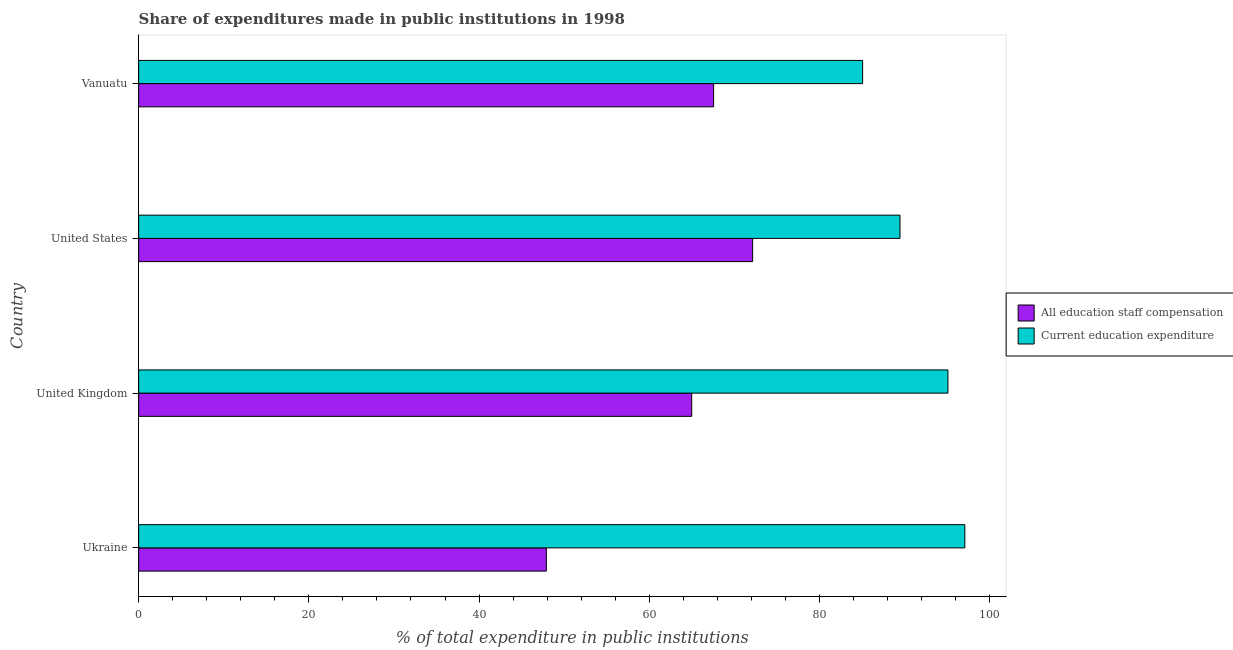How many different coloured bars are there?
Your answer should be very brief. 2. How many groups of bars are there?
Your answer should be very brief. 4. Are the number of bars per tick equal to the number of legend labels?
Keep it short and to the point. Yes. How many bars are there on the 1st tick from the top?
Give a very brief answer. 2. What is the label of the 3rd group of bars from the top?
Your answer should be compact. United Kingdom. In how many cases, is the number of bars for a given country not equal to the number of legend labels?
Offer a terse response. 0. What is the expenditure in staff compensation in Ukraine?
Your answer should be very brief. 47.91. Across all countries, what is the maximum expenditure in education?
Offer a very short reply. 97.07. Across all countries, what is the minimum expenditure in education?
Your answer should be very brief. 85.07. In which country was the expenditure in education minimum?
Keep it short and to the point. Vanuatu. What is the total expenditure in staff compensation in the graph?
Your answer should be very brief. 252.59. What is the difference between the expenditure in education in Ukraine and that in United States?
Your response must be concise. 7.62. What is the difference between the expenditure in education in United States and the expenditure in staff compensation in Ukraine?
Your answer should be very brief. 41.55. What is the average expenditure in education per country?
Offer a very short reply. 91.67. What is the difference between the expenditure in education and expenditure in staff compensation in Ukraine?
Ensure brevity in your answer.  49.17. What is the ratio of the expenditure in staff compensation in United Kingdom to that in United States?
Your answer should be very brief. 0.9. Is the difference between the expenditure in staff compensation in Ukraine and United States greater than the difference between the expenditure in education in Ukraine and United States?
Provide a succinct answer. No. What is the difference between the highest and the second highest expenditure in education?
Keep it short and to the point. 1.99. What is the difference between the highest and the lowest expenditure in education?
Provide a short and direct response. 12.01. In how many countries, is the expenditure in education greater than the average expenditure in education taken over all countries?
Make the answer very short. 2. What does the 1st bar from the top in United Kingdom represents?
Make the answer very short. Current education expenditure. What does the 1st bar from the bottom in Ukraine represents?
Provide a short and direct response. All education staff compensation. How many countries are there in the graph?
Ensure brevity in your answer.  4. What is the difference between two consecutive major ticks on the X-axis?
Give a very brief answer. 20. Are the values on the major ticks of X-axis written in scientific E-notation?
Offer a terse response. No. Does the graph contain grids?
Provide a succinct answer. No. How many legend labels are there?
Provide a short and direct response. 2. What is the title of the graph?
Your answer should be compact. Share of expenditures made in public institutions in 1998. What is the label or title of the X-axis?
Offer a very short reply. % of total expenditure in public institutions. What is the label or title of the Y-axis?
Your answer should be compact. Country. What is the % of total expenditure in public institutions in All education staff compensation in Ukraine?
Offer a terse response. 47.91. What is the % of total expenditure in public institutions of Current education expenditure in Ukraine?
Your answer should be very brief. 97.07. What is the % of total expenditure in public institutions of All education staff compensation in United Kingdom?
Provide a short and direct response. 64.98. What is the % of total expenditure in public institutions of Current education expenditure in United Kingdom?
Your answer should be compact. 95.09. What is the % of total expenditure in public institutions of All education staff compensation in United States?
Your answer should be very brief. 72.14. What is the % of total expenditure in public institutions of Current education expenditure in United States?
Your answer should be compact. 89.46. What is the % of total expenditure in public institutions in All education staff compensation in Vanuatu?
Your response must be concise. 67.56. What is the % of total expenditure in public institutions in Current education expenditure in Vanuatu?
Ensure brevity in your answer.  85.07. Across all countries, what is the maximum % of total expenditure in public institutions in All education staff compensation?
Provide a short and direct response. 72.14. Across all countries, what is the maximum % of total expenditure in public institutions of Current education expenditure?
Give a very brief answer. 97.07. Across all countries, what is the minimum % of total expenditure in public institutions of All education staff compensation?
Your answer should be very brief. 47.91. Across all countries, what is the minimum % of total expenditure in public institutions in Current education expenditure?
Ensure brevity in your answer.  85.07. What is the total % of total expenditure in public institutions in All education staff compensation in the graph?
Offer a terse response. 252.59. What is the total % of total expenditure in public institutions of Current education expenditure in the graph?
Your response must be concise. 366.69. What is the difference between the % of total expenditure in public institutions in All education staff compensation in Ukraine and that in United Kingdom?
Your response must be concise. -17.08. What is the difference between the % of total expenditure in public institutions of Current education expenditure in Ukraine and that in United Kingdom?
Give a very brief answer. 1.99. What is the difference between the % of total expenditure in public institutions of All education staff compensation in Ukraine and that in United States?
Offer a terse response. -24.24. What is the difference between the % of total expenditure in public institutions in Current education expenditure in Ukraine and that in United States?
Give a very brief answer. 7.62. What is the difference between the % of total expenditure in public institutions in All education staff compensation in Ukraine and that in Vanuatu?
Your response must be concise. -19.65. What is the difference between the % of total expenditure in public institutions in Current education expenditure in Ukraine and that in Vanuatu?
Keep it short and to the point. 12.01. What is the difference between the % of total expenditure in public institutions of All education staff compensation in United Kingdom and that in United States?
Keep it short and to the point. -7.16. What is the difference between the % of total expenditure in public institutions in Current education expenditure in United Kingdom and that in United States?
Provide a succinct answer. 5.63. What is the difference between the % of total expenditure in public institutions of All education staff compensation in United Kingdom and that in Vanuatu?
Your response must be concise. -2.57. What is the difference between the % of total expenditure in public institutions of Current education expenditure in United Kingdom and that in Vanuatu?
Offer a very short reply. 10.02. What is the difference between the % of total expenditure in public institutions in All education staff compensation in United States and that in Vanuatu?
Offer a very short reply. 4.59. What is the difference between the % of total expenditure in public institutions of Current education expenditure in United States and that in Vanuatu?
Offer a very short reply. 4.39. What is the difference between the % of total expenditure in public institutions of All education staff compensation in Ukraine and the % of total expenditure in public institutions of Current education expenditure in United Kingdom?
Your response must be concise. -47.18. What is the difference between the % of total expenditure in public institutions of All education staff compensation in Ukraine and the % of total expenditure in public institutions of Current education expenditure in United States?
Provide a succinct answer. -41.55. What is the difference between the % of total expenditure in public institutions of All education staff compensation in Ukraine and the % of total expenditure in public institutions of Current education expenditure in Vanuatu?
Provide a short and direct response. -37.16. What is the difference between the % of total expenditure in public institutions in All education staff compensation in United Kingdom and the % of total expenditure in public institutions in Current education expenditure in United States?
Provide a short and direct response. -24.47. What is the difference between the % of total expenditure in public institutions in All education staff compensation in United Kingdom and the % of total expenditure in public institutions in Current education expenditure in Vanuatu?
Provide a short and direct response. -20.08. What is the difference between the % of total expenditure in public institutions in All education staff compensation in United States and the % of total expenditure in public institutions in Current education expenditure in Vanuatu?
Ensure brevity in your answer.  -12.92. What is the average % of total expenditure in public institutions of All education staff compensation per country?
Keep it short and to the point. 63.15. What is the average % of total expenditure in public institutions in Current education expenditure per country?
Provide a succinct answer. 91.67. What is the difference between the % of total expenditure in public institutions in All education staff compensation and % of total expenditure in public institutions in Current education expenditure in Ukraine?
Give a very brief answer. -49.17. What is the difference between the % of total expenditure in public institutions of All education staff compensation and % of total expenditure in public institutions of Current education expenditure in United Kingdom?
Give a very brief answer. -30.1. What is the difference between the % of total expenditure in public institutions in All education staff compensation and % of total expenditure in public institutions in Current education expenditure in United States?
Keep it short and to the point. -17.31. What is the difference between the % of total expenditure in public institutions in All education staff compensation and % of total expenditure in public institutions in Current education expenditure in Vanuatu?
Provide a short and direct response. -17.51. What is the ratio of the % of total expenditure in public institutions in All education staff compensation in Ukraine to that in United Kingdom?
Ensure brevity in your answer.  0.74. What is the ratio of the % of total expenditure in public institutions in Current education expenditure in Ukraine to that in United Kingdom?
Your answer should be compact. 1.02. What is the ratio of the % of total expenditure in public institutions in All education staff compensation in Ukraine to that in United States?
Offer a very short reply. 0.66. What is the ratio of the % of total expenditure in public institutions in Current education expenditure in Ukraine to that in United States?
Offer a terse response. 1.09. What is the ratio of the % of total expenditure in public institutions in All education staff compensation in Ukraine to that in Vanuatu?
Provide a succinct answer. 0.71. What is the ratio of the % of total expenditure in public institutions in Current education expenditure in Ukraine to that in Vanuatu?
Provide a short and direct response. 1.14. What is the ratio of the % of total expenditure in public institutions in All education staff compensation in United Kingdom to that in United States?
Provide a succinct answer. 0.9. What is the ratio of the % of total expenditure in public institutions of Current education expenditure in United Kingdom to that in United States?
Ensure brevity in your answer.  1.06. What is the ratio of the % of total expenditure in public institutions in All education staff compensation in United Kingdom to that in Vanuatu?
Offer a very short reply. 0.96. What is the ratio of the % of total expenditure in public institutions in Current education expenditure in United Kingdom to that in Vanuatu?
Provide a succinct answer. 1.12. What is the ratio of the % of total expenditure in public institutions of All education staff compensation in United States to that in Vanuatu?
Provide a succinct answer. 1.07. What is the ratio of the % of total expenditure in public institutions of Current education expenditure in United States to that in Vanuatu?
Your answer should be compact. 1.05. What is the difference between the highest and the second highest % of total expenditure in public institutions of All education staff compensation?
Give a very brief answer. 4.59. What is the difference between the highest and the second highest % of total expenditure in public institutions of Current education expenditure?
Your answer should be compact. 1.99. What is the difference between the highest and the lowest % of total expenditure in public institutions in All education staff compensation?
Keep it short and to the point. 24.24. What is the difference between the highest and the lowest % of total expenditure in public institutions of Current education expenditure?
Give a very brief answer. 12.01. 